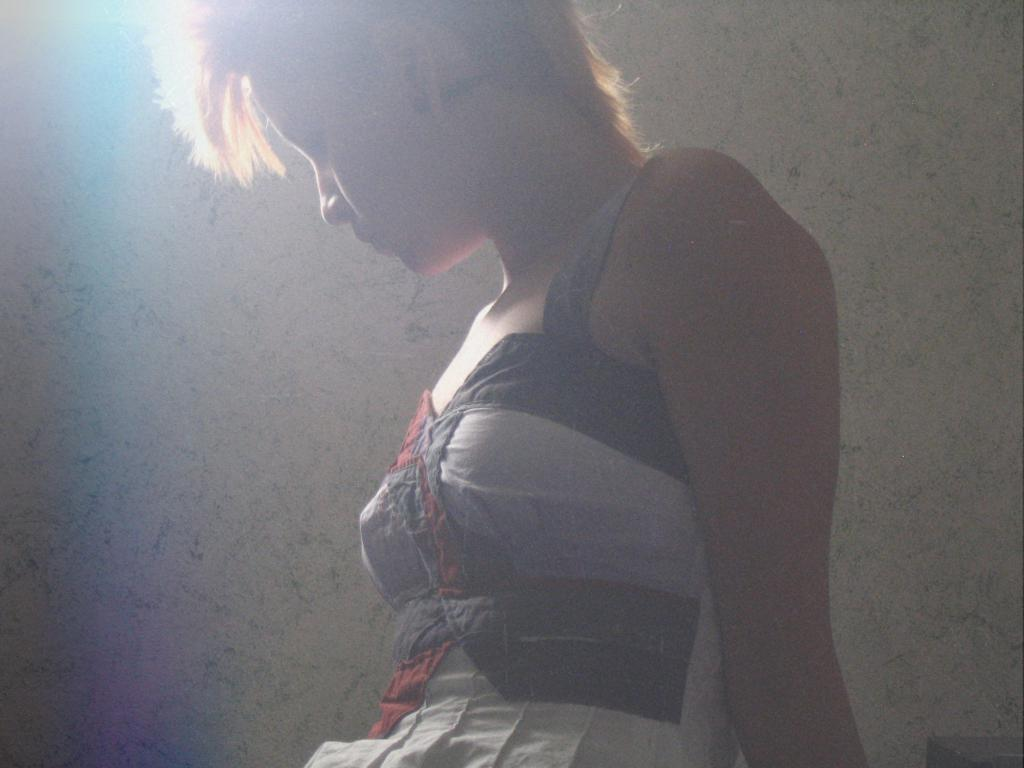Who is the main subject in the image? There is a lady in the image. What can be seen in the background of the image? There is a wall in the background of the image. How many boats are visible in the image? There are no boats present in the image. Who is the owner of the airport in the image? There is no airport present in the image. 